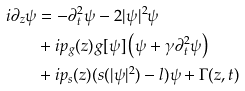Convert formula to latex. <formula><loc_0><loc_0><loc_500><loc_500>i \partial _ { z } \psi & = - \partial _ { t } ^ { 2 } \psi - 2 | \psi | ^ { 2 } \psi \\ & + i p _ { g } ( z ) g [ \psi ] \left ( \psi + \gamma \partial _ { t } ^ { 2 } \psi \right ) \\ & + i p _ { s } ( z ) ( s ( | \psi | ^ { 2 } ) - l ) \psi + \Gamma ( z , t )</formula> 